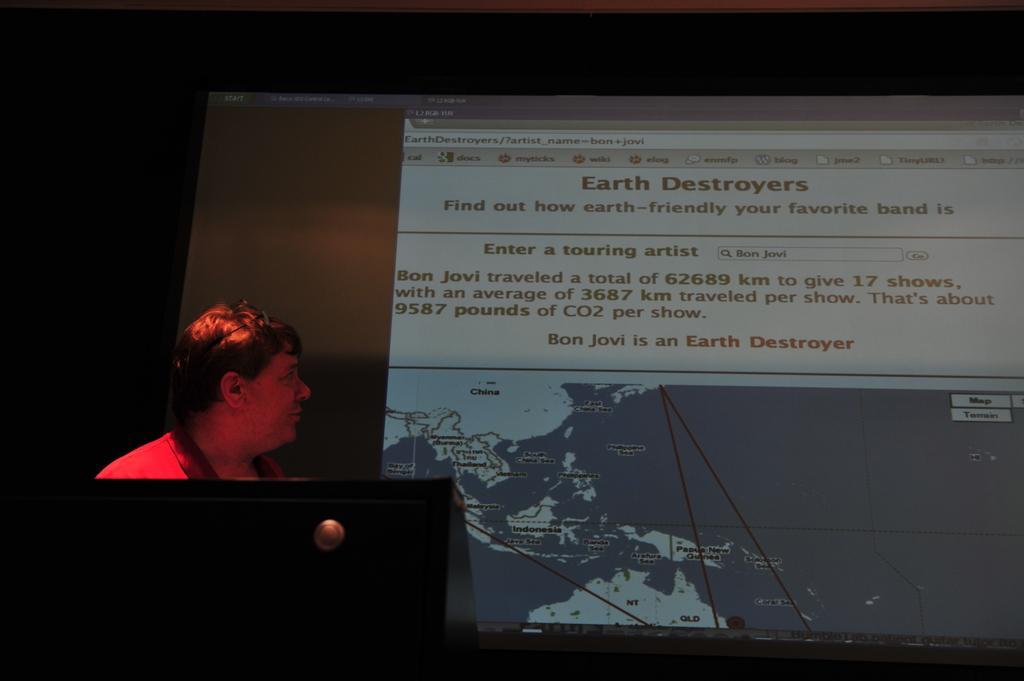Describe this image in one or two sentences. In this image I can see a person wearing red color dress is standing in front of the podium. I can see a screen and the dark background. 